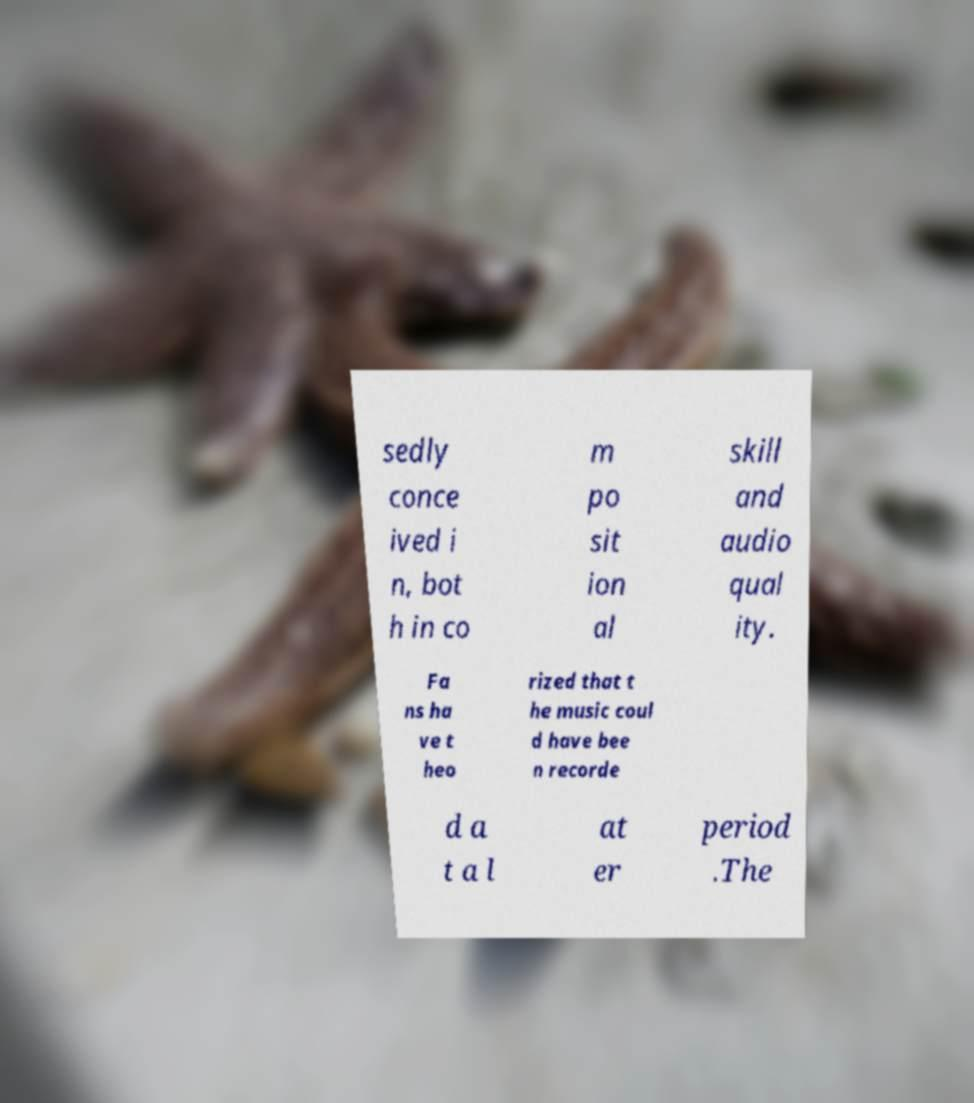Could you assist in decoding the text presented in this image and type it out clearly? sedly conce ived i n, bot h in co m po sit ion al skill and audio qual ity. Fa ns ha ve t heo rized that t he music coul d have bee n recorde d a t a l at er period .The 